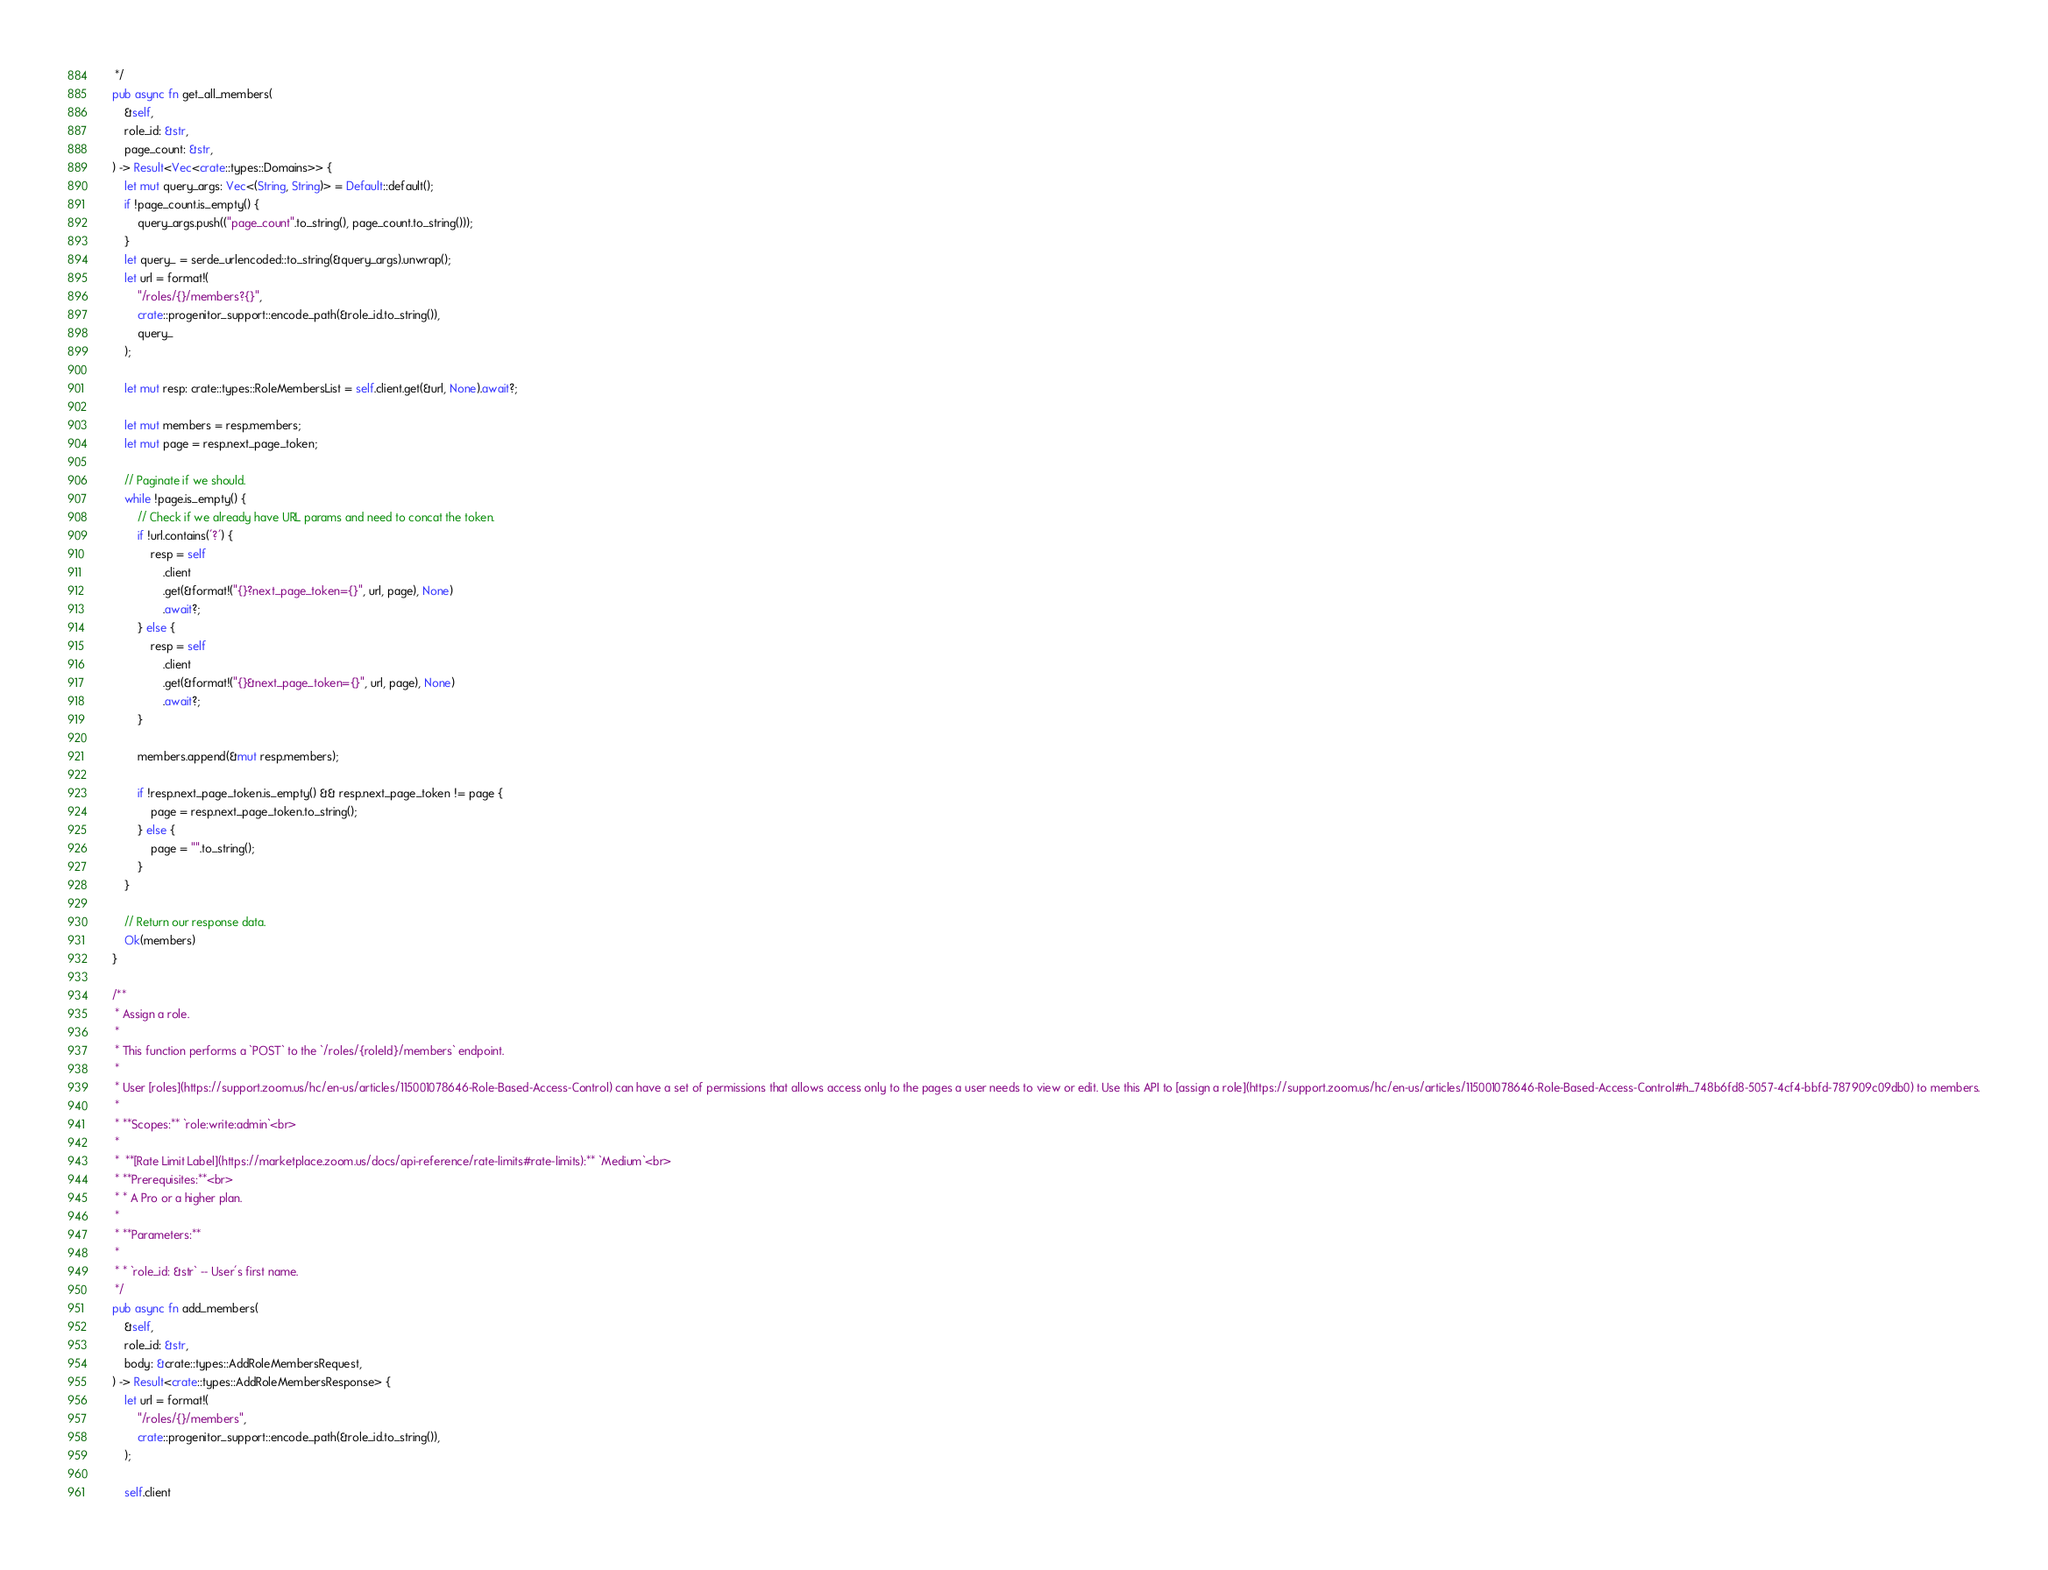<code> <loc_0><loc_0><loc_500><loc_500><_Rust_>     */
    pub async fn get_all_members(
        &self,
        role_id: &str,
        page_count: &str,
    ) -> Result<Vec<crate::types::Domains>> {
        let mut query_args: Vec<(String, String)> = Default::default();
        if !page_count.is_empty() {
            query_args.push(("page_count".to_string(), page_count.to_string()));
        }
        let query_ = serde_urlencoded::to_string(&query_args).unwrap();
        let url = format!(
            "/roles/{}/members?{}",
            crate::progenitor_support::encode_path(&role_id.to_string()),
            query_
        );

        let mut resp: crate::types::RoleMembersList = self.client.get(&url, None).await?;

        let mut members = resp.members;
        let mut page = resp.next_page_token;

        // Paginate if we should.
        while !page.is_empty() {
            // Check if we already have URL params and need to concat the token.
            if !url.contains('?') {
                resp = self
                    .client
                    .get(&format!("{}?next_page_token={}", url, page), None)
                    .await?;
            } else {
                resp = self
                    .client
                    .get(&format!("{}&next_page_token={}", url, page), None)
                    .await?;
            }

            members.append(&mut resp.members);

            if !resp.next_page_token.is_empty() && resp.next_page_token != page {
                page = resp.next_page_token.to_string();
            } else {
                page = "".to_string();
            }
        }

        // Return our response data.
        Ok(members)
    }

    /**
     * Assign a role.
     *
     * This function performs a `POST` to the `/roles/{roleId}/members` endpoint.
     *
     * User [roles](https://support.zoom.us/hc/en-us/articles/115001078646-Role-Based-Access-Control) can have a set of permissions that allows access only to the pages a user needs to view or edit. Use this API to [assign a role](https://support.zoom.us/hc/en-us/articles/115001078646-Role-Based-Access-Control#h_748b6fd8-5057-4cf4-bbfd-787909c09db0) to members.
     *
     * **Scopes:** `role:write:admin`<br>
     *  
     *  **[Rate Limit Label](https://marketplace.zoom.us/docs/api-reference/rate-limits#rate-limits):** `Medium`<br>
     * **Prerequisites:**<br>
     * * A Pro or a higher plan.
     *
     * **Parameters:**
     *
     * * `role_id: &str` -- User's first name.
     */
    pub async fn add_members(
        &self,
        role_id: &str,
        body: &crate::types::AddRoleMembersRequest,
    ) -> Result<crate::types::AddRoleMembersResponse> {
        let url = format!(
            "/roles/{}/members",
            crate::progenitor_support::encode_path(&role_id.to_string()),
        );

        self.client</code> 